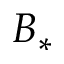Convert formula to latex. <formula><loc_0><loc_0><loc_500><loc_500>B _ { * }</formula> 